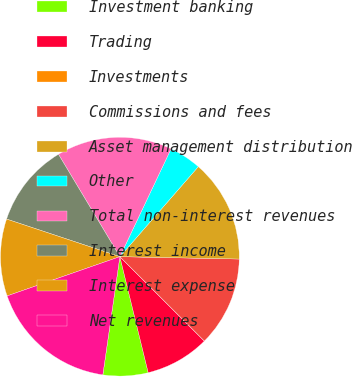Convert chart to OTSL. <chart><loc_0><loc_0><loc_500><loc_500><pie_chart><fcel>Investment banking<fcel>Trading<fcel>Investments<fcel>Commissions and fees<fcel>Asset management distribution<fcel>Other<fcel>Total non-interest revenues<fcel>Interest income<fcel>Interest expense<fcel>Net revenues<nl><fcel>6.09%<fcel>8.7%<fcel>0.0%<fcel>12.17%<fcel>13.91%<fcel>4.35%<fcel>15.65%<fcel>11.3%<fcel>10.43%<fcel>17.39%<nl></chart> 